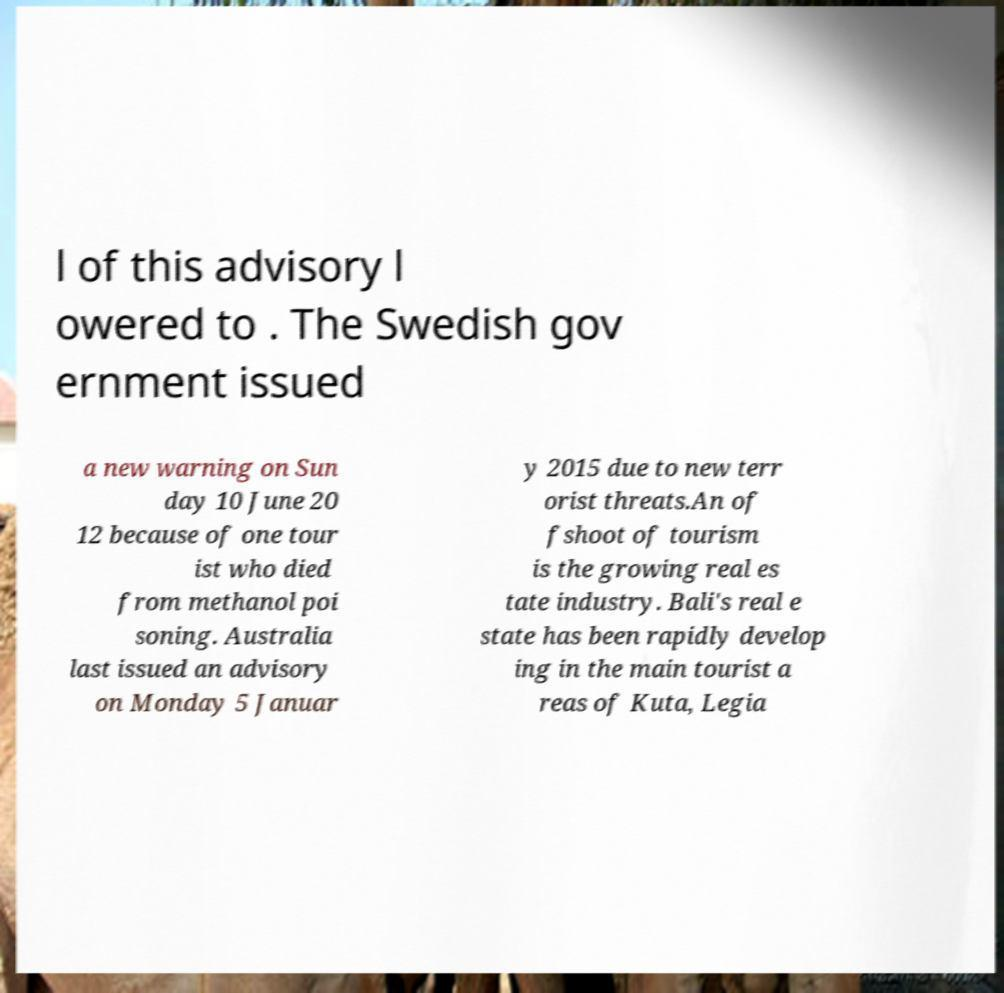Please read and relay the text visible in this image. What does it say? l of this advisory l owered to . The Swedish gov ernment issued a new warning on Sun day 10 June 20 12 because of one tour ist who died from methanol poi soning. Australia last issued an advisory on Monday 5 Januar y 2015 due to new terr orist threats.An of fshoot of tourism is the growing real es tate industry. Bali's real e state has been rapidly develop ing in the main tourist a reas of Kuta, Legia 